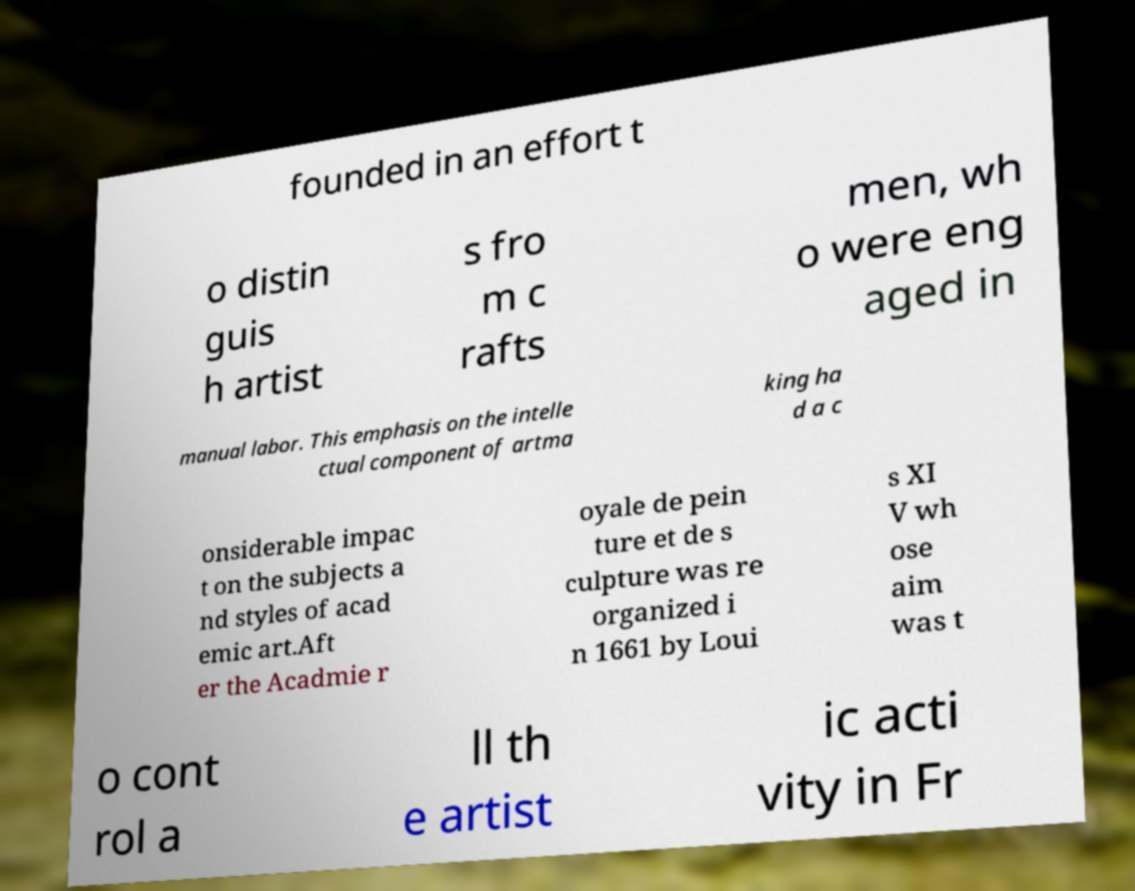Please identify and transcribe the text found in this image. founded in an effort t o distin guis h artist s fro m c rafts men, wh o were eng aged in manual labor. This emphasis on the intelle ctual component of artma king ha d a c onsiderable impac t on the subjects a nd styles of acad emic art.Aft er the Acadmie r oyale de pein ture et de s culpture was re organized i n 1661 by Loui s XI V wh ose aim was t o cont rol a ll th e artist ic acti vity in Fr 